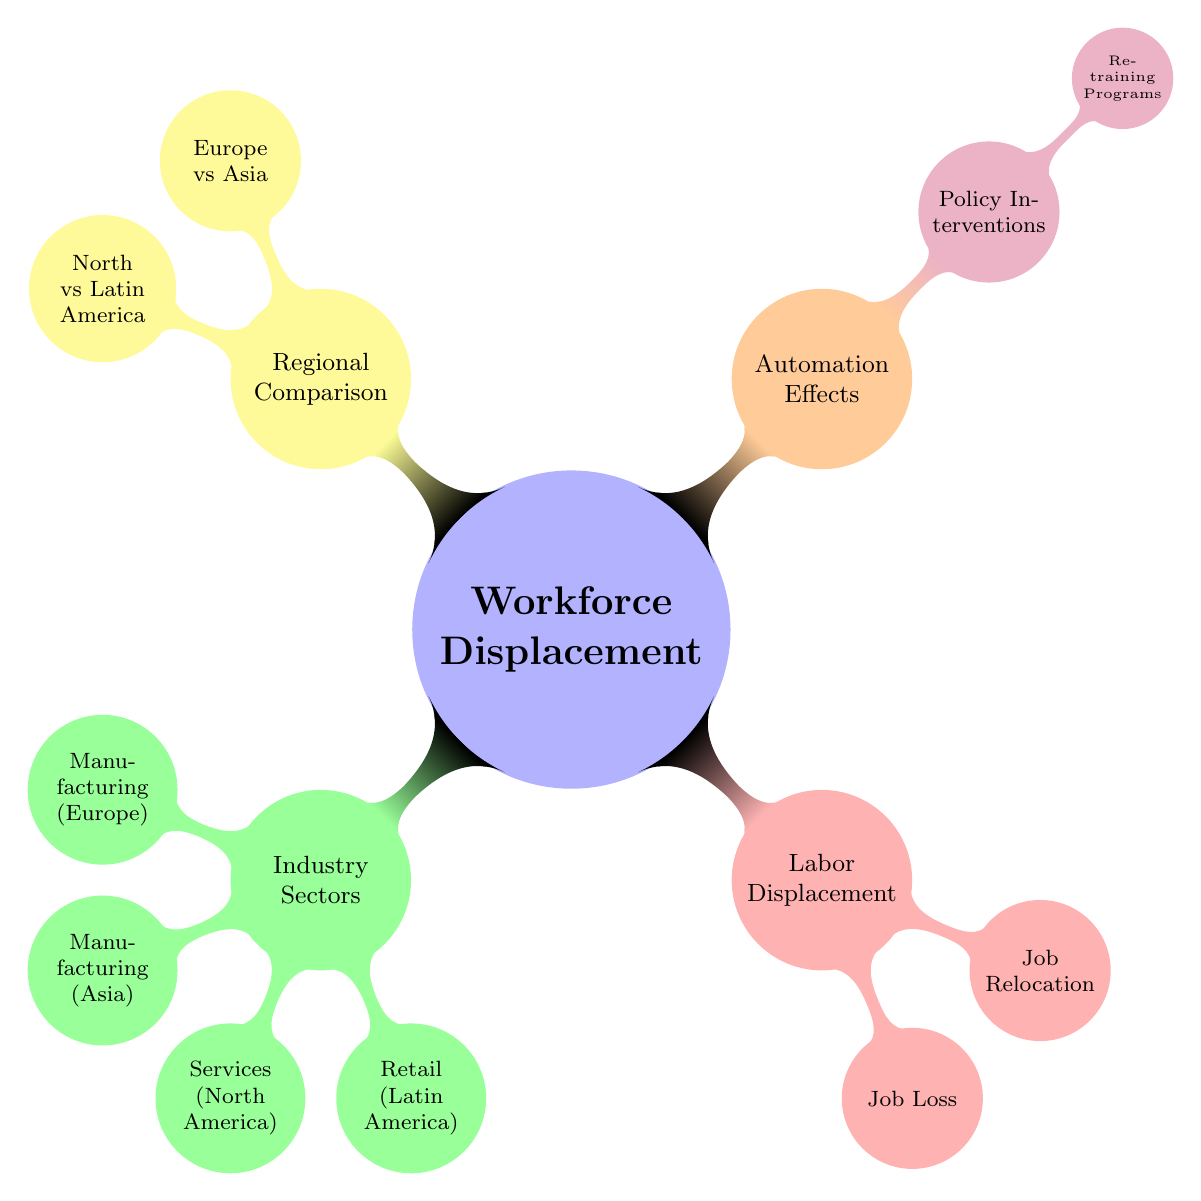What are the main categories of workforce displacement shown in the diagram? The diagram has three main categories: Industry Sectors, Labor Displacement, and Automation Effects. These are the primary branches emanating from the central concept of Workforce Displacement.
Answer: Industry Sectors, Labor Displacement, Automation Effects Which region is associated with Job Loss according to the diagram? Job Loss is a subcategory under Labor Displacement, which does not specify a particular region. Therefore, it is not directly linked to any specific region in the diagram.
Answer: No specific region How many industry sectors are listed in the diagram? The node under Industry Sectors has four branches that each represent a different sector: Manufacturing (Europe), Manufacturing (Asia), Services (North America), and Retail (Latin America). Therefore, there are four industry sectors.
Answer: Four Which two regions are compared in the Regional Comparison section? The Regional Comparison node has two child nodes that specifically indicate the regions being compared: Europe vs Asia and North vs Latin America. This shows the comparative aspect of workforce displacement across these regions.
Answer: Europe vs Asia, North vs Latin America What intervention is suggested under Automation Effects? Under the Automation Effects category, the diagram includes a branch for Policy Interventions, which leads to Retraining Programs as a suggested intervention to counteract workforce displacement.
Answer: Retraining Programs What type of labor displacement involves moving jobs from one location to another? Job Relocation, which is a branch under the Labor Displacement category, describes this type of labor displacement where jobs are moved to different locations instead of being eliminated entirely.
Answer: Job Relocation Which industry sector is associated with Latin America? The diagram indicates that the Retail sector is specifically linked to Latin America within the Industry Sectors category, making it the only sector associated with that region.
Answer: Retail (Latin America) What policy is under consideration to address automation effects? Retraining Programs are indicated under Policy Interventions within the Automation Effects category as a means to tackle the challenges posed by automation to the workforce.
Answer: Retraining Programs 